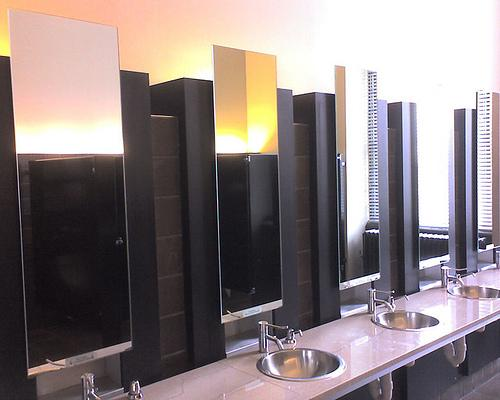What type of building is this bathroom likely to be in?

Choices:
A) house
B) business
C) library
D) school business 